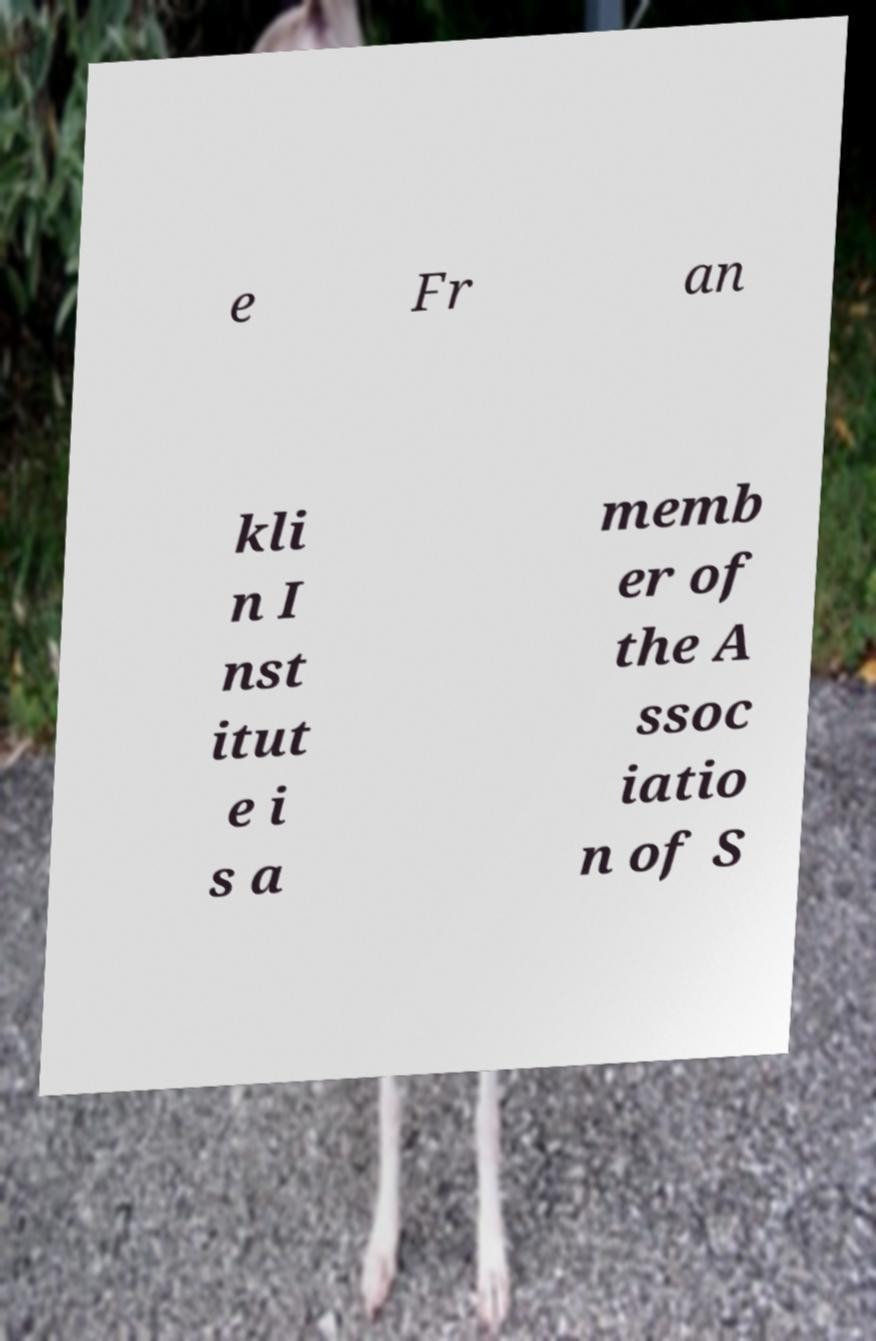For documentation purposes, I need the text within this image transcribed. Could you provide that? e Fr an kli n I nst itut e i s a memb er of the A ssoc iatio n of S 